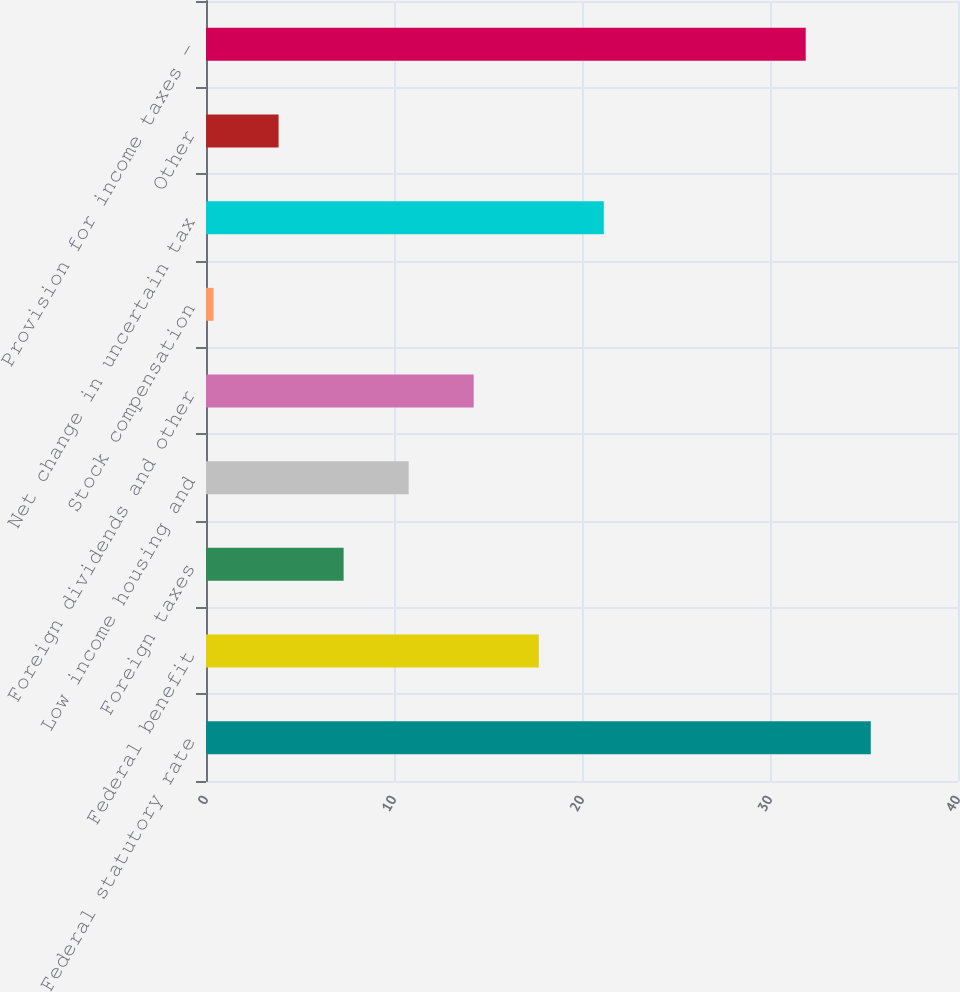Convert chart. <chart><loc_0><loc_0><loc_500><loc_500><bar_chart><fcel>Federal statutory rate<fcel>Federal benefit<fcel>Foreign taxes<fcel>Low income housing and<fcel>Foreign dividends and other<fcel>Stock compensation<fcel>Net change in uncertain tax<fcel>Other<fcel>Provision for income taxes -<nl><fcel>35.36<fcel>17.7<fcel>7.32<fcel>10.78<fcel>14.24<fcel>0.4<fcel>21.16<fcel>3.86<fcel>31.9<nl></chart> 